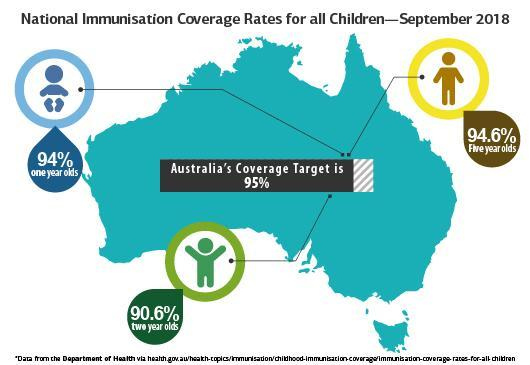What is the highest national immunisation coverage rate for children in September 2018?
Answer the question with a short phrase. 94.6% Which age group of children has the highest immunisation coverage rate in September 2018? Five year olds Which age group of children has the lowest immunisation coverage rate in September 2018? two year olds What is the lowest immunisation coverage rate for children in September 2018? 90.6% 